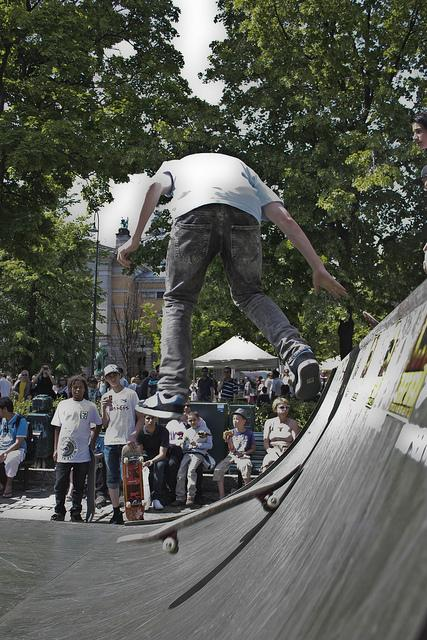Why is he in the air above the skateboard? Please explain your reasoning. showing off. The man is showing off tricks. 